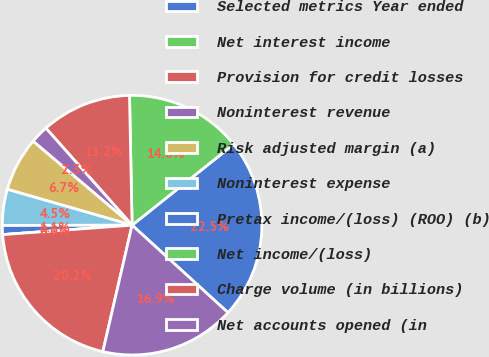Convert chart to OTSL. <chart><loc_0><loc_0><loc_500><loc_500><pie_chart><fcel>Selected metrics Year ended<fcel>Net interest income<fcel>Provision for credit losses<fcel>Noninterest revenue<fcel>Risk adjusted margin (a)<fcel>Noninterest expense<fcel>Pretax income/(loss) (ROO) (b)<fcel>Net income/(loss)<fcel>Charge volume (in billions)<fcel>Net accounts opened (in<nl><fcel>22.47%<fcel>14.61%<fcel>11.24%<fcel>2.25%<fcel>6.74%<fcel>4.49%<fcel>1.12%<fcel>0.0%<fcel>20.22%<fcel>16.85%<nl></chart> 